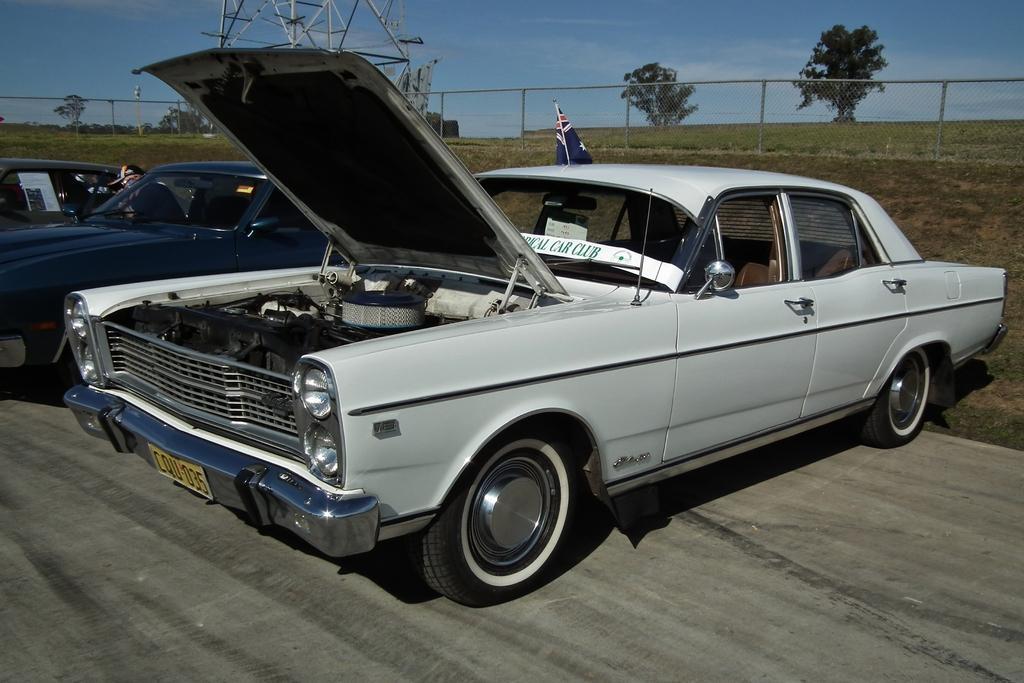Please provide a concise description of this image. In this image there are vehicles. In the background there is grass on the ground and there is a fence, there are trees, there is a tower and there is a flag and the sky is cloudy. 